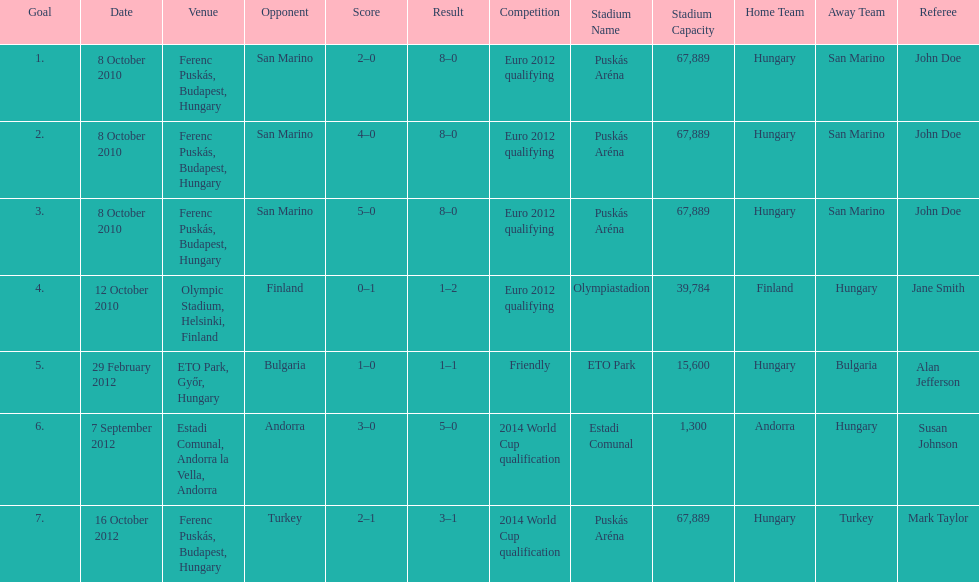What is the number of goals ádám szalai made against san marino in 2010? 3. 